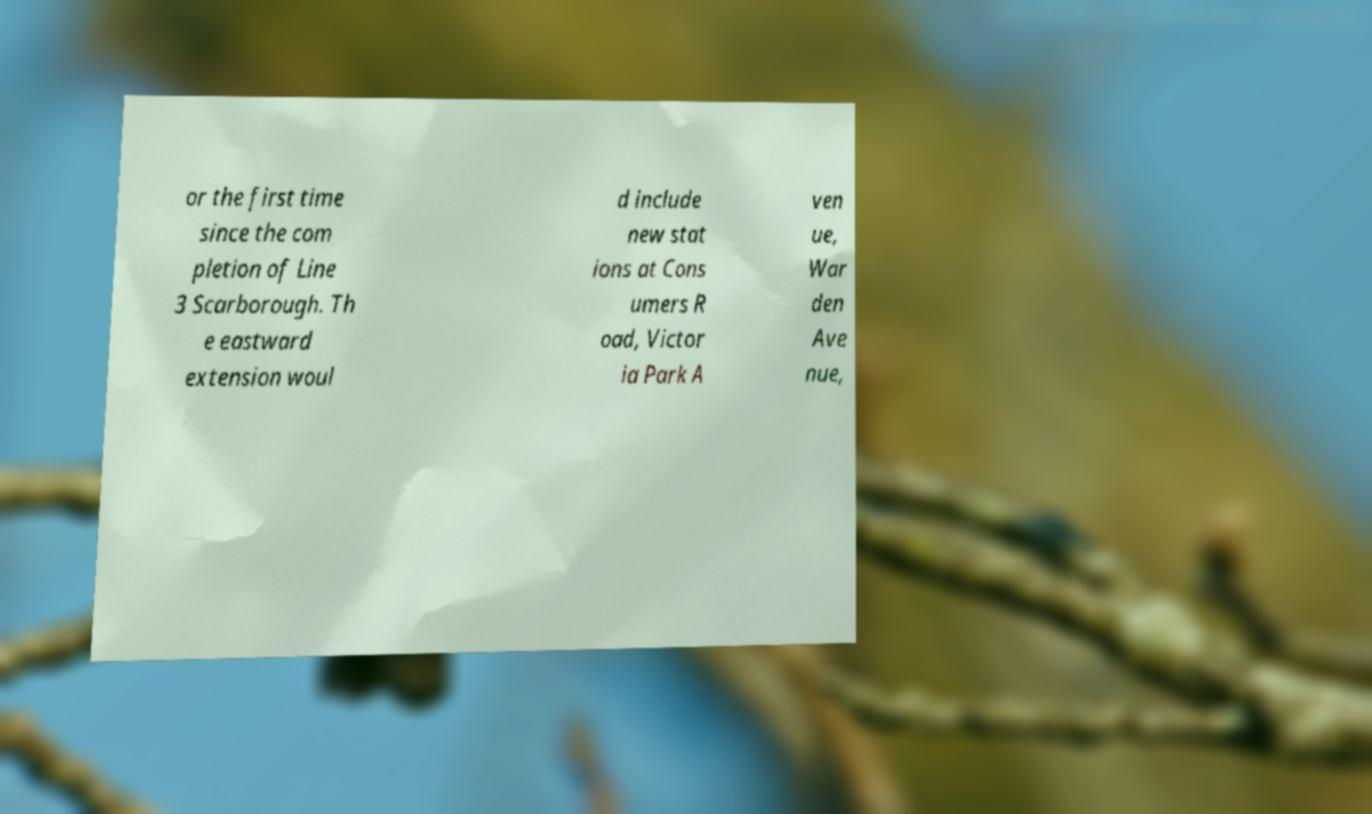Could you extract and type out the text from this image? or the first time since the com pletion of Line 3 Scarborough. Th e eastward extension woul d include new stat ions at Cons umers R oad, Victor ia Park A ven ue, War den Ave nue, 